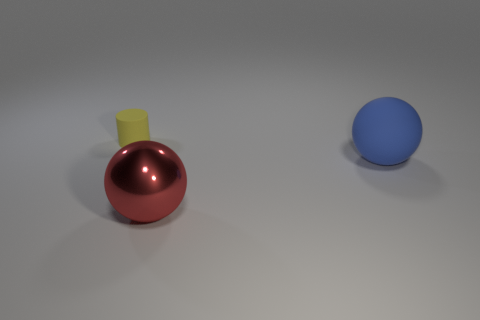Add 2 large rubber spheres. How many objects exist? 5 Subtract all cylinders. How many objects are left? 2 Add 1 large cyan shiny balls. How many large cyan shiny balls exist? 1 Subtract 0 red cylinders. How many objects are left? 3 Subtract all large blue cubes. Subtract all large matte spheres. How many objects are left? 2 Add 1 large rubber objects. How many large rubber objects are left? 2 